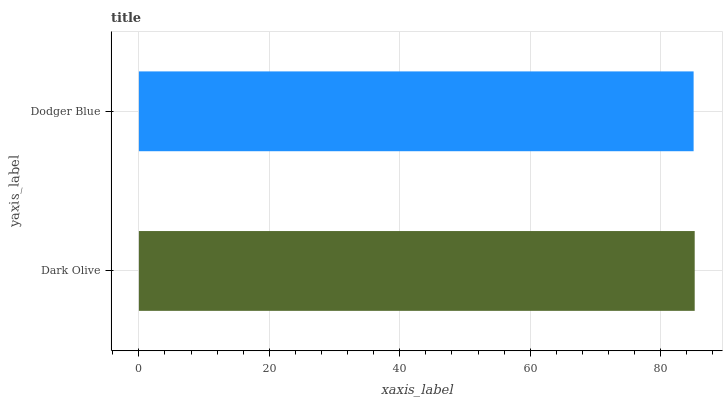Is Dodger Blue the minimum?
Answer yes or no. Yes. Is Dark Olive the maximum?
Answer yes or no. Yes. Is Dodger Blue the maximum?
Answer yes or no. No. Is Dark Olive greater than Dodger Blue?
Answer yes or no. Yes. Is Dodger Blue less than Dark Olive?
Answer yes or no. Yes. Is Dodger Blue greater than Dark Olive?
Answer yes or no. No. Is Dark Olive less than Dodger Blue?
Answer yes or no. No. Is Dark Olive the high median?
Answer yes or no. Yes. Is Dodger Blue the low median?
Answer yes or no. Yes. Is Dodger Blue the high median?
Answer yes or no. No. Is Dark Olive the low median?
Answer yes or no. No. 